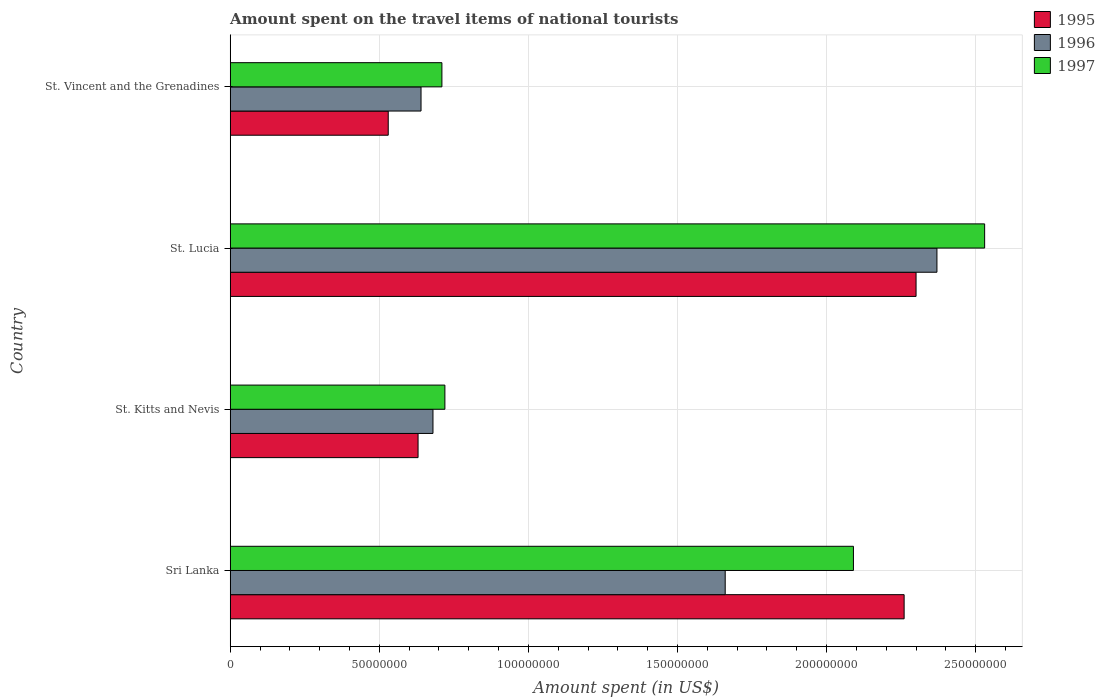How many groups of bars are there?
Keep it short and to the point. 4. What is the label of the 3rd group of bars from the top?
Ensure brevity in your answer.  St. Kitts and Nevis. In how many cases, is the number of bars for a given country not equal to the number of legend labels?
Ensure brevity in your answer.  0. What is the amount spent on the travel items of national tourists in 1997 in St. Kitts and Nevis?
Keep it short and to the point. 7.20e+07. Across all countries, what is the maximum amount spent on the travel items of national tourists in 1997?
Offer a terse response. 2.53e+08. Across all countries, what is the minimum amount spent on the travel items of national tourists in 1996?
Your response must be concise. 6.40e+07. In which country was the amount spent on the travel items of national tourists in 1997 maximum?
Your answer should be compact. St. Lucia. In which country was the amount spent on the travel items of national tourists in 1997 minimum?
Provide a succinct answer. St. Vincent and the Grenadines. What is the total amount spent on the travel items of national tourists in 1996 in the graph?
Offer a very short reply. 5.35e+08. What is the difference between the amount spent on the travel items of national tourists in 1997 in St. Lucia and that in St. Vincent and the Grenadines?
Your answer should be very brief. 1.82e+08. What is the difference between the amount spent on the travel items of national tourists in 1997 in St. Vincent and the Grenadines and the amount spent on the travel items of national tourists in 1995 in St. Lucia?
Make the answer very short. -1.59e+08. What is the average amount spent on the travel items of national tourists in 1996 per country?
Your response must be concise. 1.34e+08. What is the difference between the amount spent on the travel items of national tourists in 1995 and amount spent on the travel items of national tourists in 1997 in Sri Lanka?
Give a very brief answer. 1.70e+07. What is the ratio of the amount spent on the travel items of national tourists in 1996 in St. Lucia to that in St. Vincent and the Grenadines?
Your answer should be very brief. 3.7. Is the amount spent on the travel items of national tourists in 1995 in St. Lucia less than that in St. Vincent and the Grenadines?
Give a very brief answer. No. Is the difference between the amount spent on the travel items of national tourists in 1995 in Sri Lanka and St. Kitts and Nevis greater than the difference between the amount spent on the travel items of national tourists in 1997 in Sri Lanka and St. Kitts and Nevis?
Provide a succinct answer. Yes. What is the difference between the highest and the lowest amount spent on the travel items of national tourists in 1996?
Provide a succinct answer. 1.73e+08. What does the 3rd bar from the top in St. Vincent and the Grenadines represents?
Your response must be concise. 1995. What does the 1st bar from the bottom in Sri Lanka represents?
Keep it short and to the point. 1995. Is it the case that in every country, the sum of the amount spent on the travel items of national tourists in 1997 and amount spent on the travel items of national tourists in 1995 is greater than the amount spent on the travel items of national tourists in 1996?
Provide a short and direct response. Yes. How many countries are there in the graph?
Ensure brevity in your answer.  4. Where does the legend appear in the graph?
Keep it short and to the point. Top right. How many legend labels are there?
Provide a succinct answer. 3. How are the legend labels stacked?
Give a very brief answer. Vertical. What is the title of the graph?
Keep it short and to the point. Amount spent on the travel items of national tourists. What is the label or title of the X-axis?
Ensure brevity in your answer.  Amount spent (in US$). What is the Amount spent (in US$) in 1995 in Sri Lanka?
Provide a succinct answer. 2.26e+08. What is the Amount spent (in US$) of 1996 in Sri Lanka?
Offer a very short reply. 1.66e+08. What is the Amount spent (in US$) in 1997 in Sri Lanka?
Keep it short and to the point. 2.09e+08. What is the Amount spent (in US$) in 1995 in St. Kitts and Nevis?
Provide a succinct answer. 6.30e+07. What is the Amount spent (in US$) in 1996 in St. Kitts and Nevis?
Offer a terse response. 6.80e+07. What is the Amount spent (in US$) in 1997 in St. Kitts and Nevis?
Your response must be concise. 7.20e+07. What is the Amount spent (in US$) of 1995 in St. Lucia?
Offer a terse response. 2.30e+08. What is the Amount spent (in US$) in 1996 in St. Lucia?
Your answer should be compact. 2.37e+08. What is the Amount spent (in US$) of 1997 in St. Lucia?
Offer a very short reply. 2.53e+08. What is the Amount spent (in US$) of 1995 in St. Vincent and the Grenadines?
Provide a short and direct response. 5.30e+07. What is the Amount spent (in US$) of 1996 in St. Vincent and the Grenadines?
Provide a short and direct response. 6.40e+07. What is the Amount spent (in US$) in 1997 in St. Vincent and the Grenadines?
Provide a succinct answer. 7.10e+07. Across all countries, what is the maximum Amount spent (in US$) in 1995?
Ensure brevity in your answer.  2.30e+08. Across all countries, what is the maximum Amount spent (in US$) in 1996?
Your answer should be very brief. 2.37e+08. Across all countries, what is the maximum Amount spent (in US$) of 1997?
Give a very brief answer. 2.53e+08. Across all countries, what is the minimum Amount spent (in US$) of 1995?
Offer a terse response. 5.30e+07. Across all countries, what is the minimum Amount spent (in US$) of 1996?
Provide a short and direct response. 6.40e+07. Across all countries, what is the minimum Amount spent (in US$) in 1997?
Offer a terse response. 7.10e+07. What is the total Amount spent (in US$) of 1995 in the graph?
Offer a very short reply. 5.72e+08. What is the total Amount spent (in US$) in 1996 in the graph?
Your answer should be compact. 5.35e+08. What is the total Amount spent (in US$) in 1997 in the graph?
Provide a succinct answer. 6.05e+08. What is the difference between the Amount spent (in US$) of 1995 in Sri Lanka and that in St. Kitts and Nevis?
Ensure brevity in your answer.  1.63e+08. What is the difference between the Amount spent (in US$) of 1996 in Sri Lanka and that in St. Kitts and Nevis?
Your response must be concise. 9.80e+07. What is the difference between the Amount spent (in US$) of 1997 in Sri Lanka and that in St. Kitts and Nevis?
Keep it short and to the point. 1.37e+08. What is the difference between the Amount spent (in US$) of 1995 in Sri Lanka and that in St. Lucia?
Give a very brief answer. -4.00e+06. What is the difference between the Amount spent (in US$) in 1996 in Sri Lanka and that in St. Lucia?
Keep it short and to the point. -7.10e+07. What is the difference between the Amount spent (in US$) in 1997 in Sri Lanka and that in St. Lucia?
Make the answer very short. -4.40e+07. What is the difference between the Amount spent (in US$) in 1995 in Sri Lanka and that in St. Vincent and the Grenadines?
Offer a very short reply. 1.73e+08. What is the difference between the Amount spent (in US$) of 1996 in Sri Lanka and that in St. Vincent and the Grenadines?
Provide a short and direct response. 1.02e+08. What is the difference between the Amount spent (in US$) of 1997 in Sri Lanka and that in St. Vincent and the Grenadines?
Provide a short and direct response. 1.38e+08. What is the difference between the Amount spent (in US$) in 1995 in St. Kitts and Nevis and that in St. Lucia?
Give a very brief answer. -1.67e+08. What is the difference between the Amount spent (in US$) of 1996 in St. Kitts and Nevis and that in St. Lucia?
Offer a very short reply. -1.69e+08. What is the difference between the Amount spent (in US$) of 1997 in St. Kitts and Nevis and that in St. Lucia?
Your answer should be compact. -1.81e+08. What is the difference between the Amount spent (in US$) of 1995 in St. Lucia and that in St. Vincent and the Grenadines?
Your answer should be compact. 1.77e+08. What is the difference between the Amount spent (in US$) in 1996 in St. Lucia and that in St. Vincent and the Grenadines?
Make the answer very short. 1.73e+08. What is the difference between the Amount spent (in US$) of 1997 in St. Lucia and that in St. Vincent and the Grenadines?
Make the answer very short. 1.82e+08. What is the difference between the Amount spent (in US$) in 1995 in Sri Lanka and the Amount spent (in US$) in 1996 in St. Kitts and Nevis?
Make the answer very short. 1.58e+08. What is the difference between the Amount spent (in US$) of 1995 in Sri Lanka and the Amount spent (in US$) of 1997 in St. Kitts and Nevis?
Offer a very short reply. 1.54e+08. What is the difference between the Amount spent (in US$) in 1996 in Sri Lanka and the Amount spent (in US$) in 1997 in St. Kitts and Nevis?
Your answer should be very brief. 9.40e+07. What is the difference between the Amount spent (in US$) of 1995 in Sri Lanka and the Amount spent (in US$) of 1996 in St. Lucia?
Ensure brevity in your answer.  -1.10e+07. What is the difference between the Amount spent (in US$) of 1995 in Sri Lanka and the Amount spent (in US$) of 1997 in St. Lucia?
Provide a short and direct response. -2.70e+07. What is the difference between the Amount spent (in US$) of 1996 in Sri Lanka and the Amount spent (in US$) of 1997 in St. Lucia?
Your answer should be very brief. -8.70e+07. What is the difference between the Amount spent (in US$) in 1995 in Sri Lanka and the Amount spent (in US$) in 1996 in St. Vincent and the Grenadines?
Your answer should be compact. 1.62e+08. What is the difference between the Amount spent (in US$) in 1995 in Sri Lanka and the Amount spent (in US$) in 1997 in St. Vincent and the Grenadines?
Ensure brevity in your answer.  1.55e+08. What is the difference between the Amount spent (in US$) of 1996 in Sri Lanka and the Amount spent (in US$) of 1997 in St. Vincent and the Grenadines?
Keep it short and to the point. 9.50e+07. What is the difference between the Amount spent (in US$) in 1995 in St. Kitts and Nevis and the Amount spent (in US$) in 1996 in St. Lucia?
Ensure brevity in your answer.  -1.74e+08. What is the difference between the Amount spent (in US$) of 1995 in St. Kitts and Nevis and the Amount spent (in US$) of 1997 in St. Lucia?
Your answer should be very brief. -1.90e+08. What is the difference between the Amount spent (in US$) in 1996 in St. Kitts and Nevis and the Amount spent (in US$) in 1997 in St. Lucia?
Your answer should be compact. -1.85e+08. What is the difference between the Amount spent (in US$) of 1995 in St. Kitts and Nevis and the Amount spent (in US$) of 1997 in St. Vincent and the Grenadines?
Your answer should be compact. -8.00e+06. What is the difference between the Amount spent (in US$) in 1995 in St. Lucia and the Amount spent (in US$) in 1996 in St. Vincent and the Grenadines?
Provide a succinct answer. 1.66e+08. What is the difference between the Amount spent (in US$) of 1995 in St. Lucia and the Amount spent (in US$) of 1997 in St. Vincent and the Grenadines?
Your answer should be compact. 1.59e+08. What is the difference between the Amount spent (in US$) in 1996 in St. Lucia and the Amount spent (in US$) in 1997 in St. Vincent and the Grenadines?
Keep it short and to the point. 1.66e+08. What is the average Amount spent (in US$) in 1995 per country?
Your answer should be very brief. 1.43e+08. What is the average Amount spent (in US$) of 1996 per country?
Offer a very short reply. 1.34e+08. What is the average Amount spent (in US$) of 1997 per country?
Your answer should be very brief. 1.51e+08. What is the difference between the Amount spent (in US$) in 1995 and Amount spent (in US$) in 1996 in Sri Lanka?
Your response must be concise. 6.00e+07. What is the difference between the Amount spent (in US$) of 1995 and Amount spent (in US$) of 1997 in Sri Lanka?
Give a very brief answer. 1.70e+07. What is the difference between the Amount spent (in US$) in 1996 and Amount spent (in US$) in 1997 in Sri Lanka?
Your answer should be compact. -4.30e+07. What is the difference between the Amount spent (in US$) of 1995 and Amount spent (in US$) of 1996 in St. Kitts and Nevis?
Keep it short and to the point. -5.00e+06. What is the difference between the Amount spent (in US$) in 1995 and Amount spent (in US$) in 1997 in St. Kitts and Nevis?
Ensure brevity in your answer.  -9.00e+06. What is the difference between the Amount spent (in US$) of 1996 and Amount spent (in US$) of 1997 in St. Kitts and Nevis?
Your answer should be compact. -4.00e+06. What is the difference between the Amount spent (in US$) in 1995 and Amount spent (in US$) in 1996 in St. Lucia?
Ensure brevity in your answer.  -7.00e+06. What is the difference between the Amount spent (in US$) in 1995 and Amount spent (in US$) in 1997 in St. Lucia?
Provide a succinct answer. -2.30e+07. What is the difference between the Amount spent (in US$) of 1996 and Amount spent (in US$) of 1997 in St. Lucia?
Offer a very short reply. -1.60e+07. What is the difference between the Amount spent (in US$) in 1995 and Amount spent (in US$) in 1996 in St. Vincent and the Grenadines?
Your response must be concise. -1.10e+07. What is the difference between the Amount spent (in US$) of 1995 and Amount spent (in US$) of 1997 in St. Vincent and the Grenadines?
Give a very brief answer. -1.80e+07. What is the difference between the Amount spent (in US$) of 1996 and Amount spent (in US$) of 1997 in St. Vincent and the Grenadines?
Provide a short and direct response. -7.00e+06. What is the ratio of the Amount spent (in US$) of 1995 in Sri Lanka to that in St. Kitts and Nevis?
Your answer should be very brief. 3.59. What is the ratio of the Amount spent (in US$) of 1996 in Sri Lanka to that in St. Kitts and Nevis?
Offer a terse response. 2.44. What is the ratio of the Amount spent (in US$) in 1997 in Sri Lanka to that in St. Kitts and Nevis?
Make the answer very short. 2.9. What is the ratio of the Amount spent (in US$) in 1995 in Sri Lanka to that in St. Lucia?
Ensure brevity in your answer.  0.98. What is the ratio of the Amount spent (in US$) in 1996 in Sri Lanka to that in St. Lucia?
Provide a succinct answer. 0.7. What is the ratio of the Amount spent (in US$) of 1997 in Sri Lanka to that in St. Lucia?
Offer a very short reply. 0.83. What is the ratio of the Amount spent (in US$) of 1995 in Sri Lanka to that in St. Vincent and the Grenadines?
Your response must be concise. 4.26. What is the ratio of the Amount spent (in US$) in 1996 in Sri Lanka to that in St. Vincent and the Grenadines?
Your response must be concise. 2.59. What is the ratio of the Amount spent (in US$) in 1997 in Sri Lanka to that in St. Vincent and the Grenadines?
Your answer should be very brief. 2.94. What is the ratio of the Amount spent (in US$) in 1995 in St. Kitts and Nevis to that in St. Lucia?
Provide a short and direct response. 0.27. What is the ratio of the Amount spent (in US$) of 1996 in St. Kitts and Nevis to that in St. Lucia?
Keep it short and to the point. 0.29. What is the ratio of the Amount spent (in US$) of 1997 in St. Kitts and Nevis to that in St. Lucia?
Keep it short and to the point. 0.28. What is the ratio of the Amount spent (in US$) of 1995 in St. Kitts and Nevis to that in St. Vincent and the Grenadines?
Your response must be concise. 1.19. What is the ratio of the Amount spent (in US$) of 1996 in St. Kitts and Nevis to that in St. Vincent and the Grenadines?
Your answer should be compact. 1.06. What is the ratio of the Amount spent (in US$) in 1997 in St. Kitts and Nevis to that in St. Vincent and the Grenadines?
Offer a very short reply. 1.01. What is the ratio of the Amount spent (in US$) in 1995 in St. Lucia to that in St. Vincent and the Grenadines?
Ensure brevity in your answer.  4.34. What is the ratio of the Amount spent (in US$) of 1996 in St. Lucia to that in St. Vincent and the Grenadines?
Offer a terse response. 3.7. What is the ratio of the Amount spent (in US$) in 1997 in St. Lucia to that in St. Vincent and the Grenadines?
Ensure brevity in your answer.  3.56. What is the difference between the highest and the second highest Amount spent (in US$) of 1995?
Your answer should be very brief. 4.00e+06. What is the difference between the highest and the second highest Amount spent (in US$) of 1996?
Ensure brevity in your answer.  7.10e+07. What is the difference between the highest and the second highest Amount spent (in US$) in 1997?
Give a very brief answer. 4.40e+07. What is the difference between the highest and the lowest Amount spent (in US$) in 1995?
Your response must be concise. 1.77e+08. What is the difference between the highest and the lowest Amount spent (in US$) in 1996?
Offer a very short reply. 1.73e+08. What is the difference between the highest and the lowest Amount spent (in US$) in 1997?
Provide a short and direct response. 1.82e+08. 